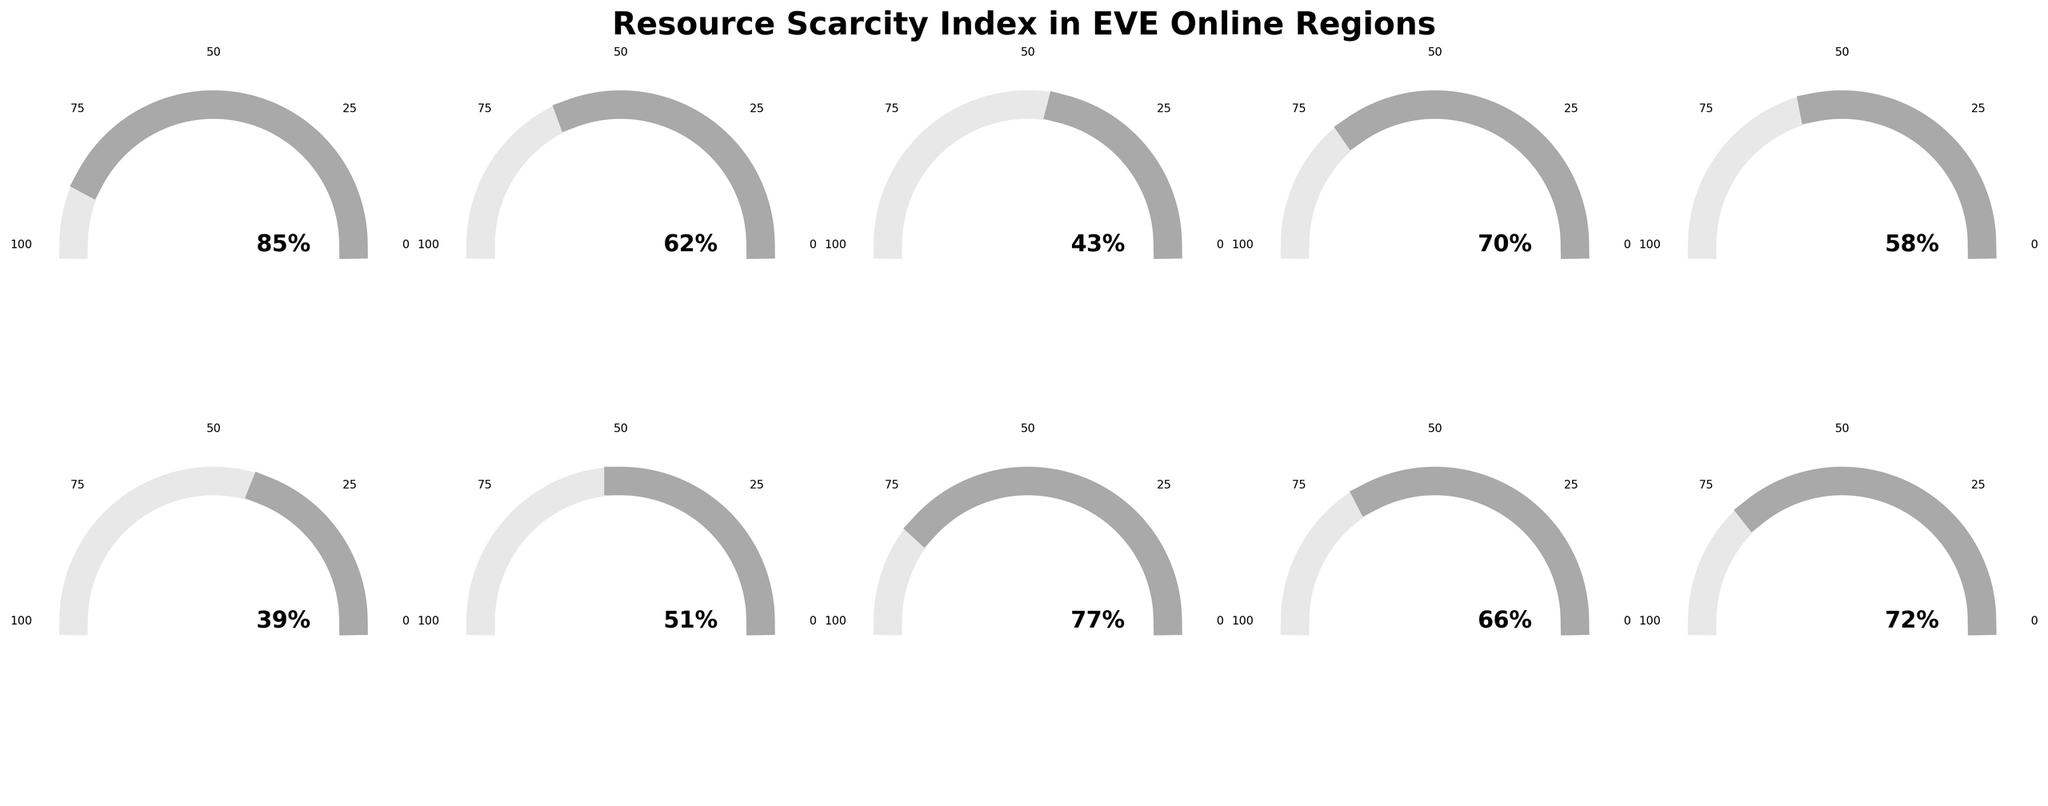How many regions are displayed in the figure? Count the number of regions listed in the figure. There are 10 regions in total.
Answer: 10 Which region has the highest Resource Scarcity Index? The Forge has a scarcity index of 85, which is the highest among all regions.
Answer: The Forge Which regions have scarcity indices above 70? Look at each region's index: The Forge (85), Domain (70), Derelik (77), Khanid (72). Thus, The Forge, Derelik, and Khanid have indices above 70.
Answer: The Forge, Derelik, Khanid What's the average Resource Scarcity Index for all regions? Add all the indices and divide by the number of regions: (85 + 62 + 43 + 70 + 58 + 39 + 51 + 77 + 66 + 72) / 10 = 62.3.
Answer: 62.3 Which region has a scarcity index closest to the average index? The average index is 62.3. Heimatar has an index of 62, which is the closest to 62.3.
Answer: Heimatar What is the difference between the highest and lowest Resource Scarcity Indices? The highest index is 85 (The Forge) and the lowest is 39 (Metropolis). The difference is 85 - 39 = 46.
Answer: 46 Which regions have Resource Scarcity Indices below the average? The average is 62.3. Sinq Laison (43), Metropolis (39), Essence (51), and Lonetrek (58) are below this average.
Answer: Sinq Laison, Metropolis, Essence, Lonetrek Is the Resource Scarcity Index of Domain closer to that of Tash-Murkon or Derelik? Domain has an index of 70, Tash-Murkon has 66, and Derelik has 77. The difference with Tash-Murkon is 4 (70 - 66), and with Derelik is 7 (77 - 70). Therefore, it is closer to Tash-Murkon.
Answer: Tash-Murkon What is the median Resource Scarcity Index value among the regions? Arrange the indices: 39, 43, 51, 58, 62, 66, 70, 72, 77, 85. The median value (the middle one in an ordered list) is the average of 62 and 66: (62 + 66) / 2 = 64.
Answer: 64 